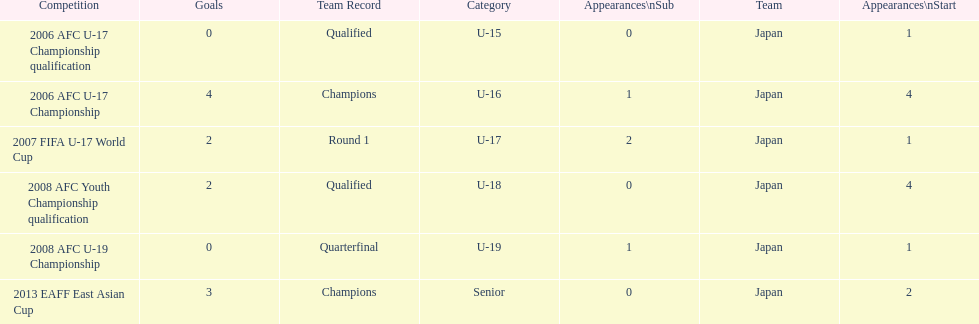Name the earliest competition to have a sub. 2006 AFC U-17 Championship. 